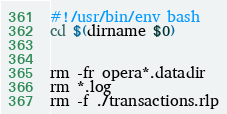Convert code to text. <code><loc_0><loc_0><loc_500><loc_500><_Bash_>#!/usr/bin/env bash
cd $(dirname $0)


rm -fr opera*.datadir
rm *.log
rm -f ./transactions.rlp</code> 